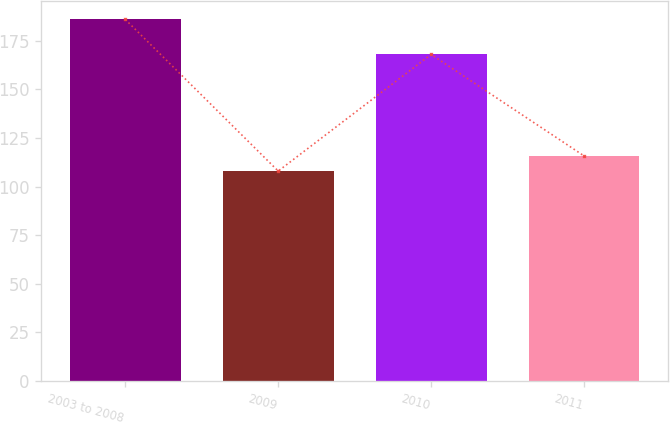<chart> <loc_0><loc_0><loc_500><loc_500><bar_chart><fcel>2003 to 2008<fcel>2009<fcel>2010<fcel>2011<nl><fcel>186<fcel>108<fcel>168<fcel>115.8<nl></chart> 